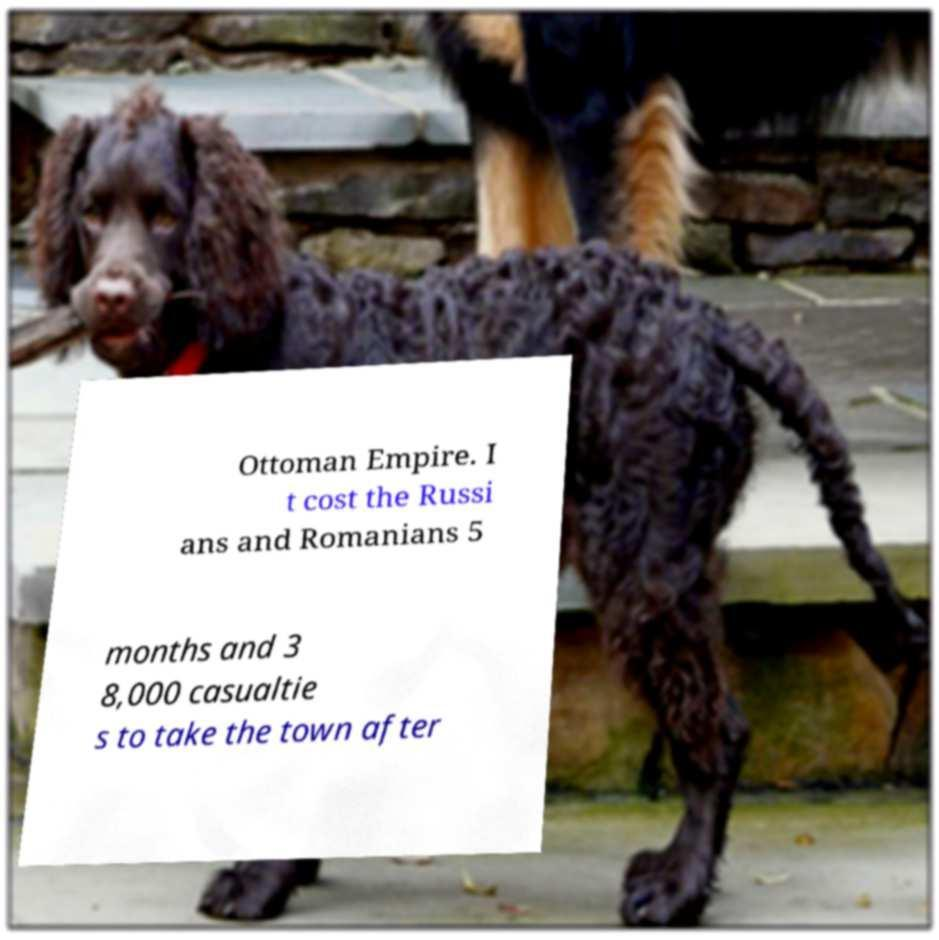Please identify and transcribe the text found in this image. Ottoman Empire. I t cost the Russi ans and Romanians 5 months and 3 8,000 casualtie s to take the town after 